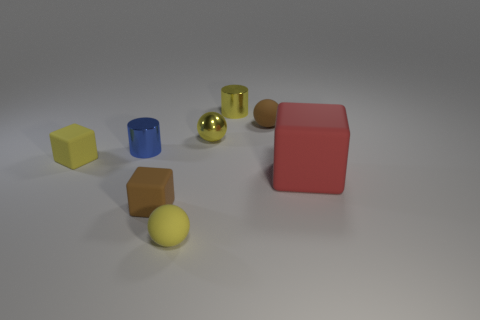There is a shiny object that is the same color as the small shiny sphere; what size is it?
Provide a succinct answer. Small. There is a small yellow shiny cylinder behind the big rubber thing; how many tiny brown things are to the left of it?
Provide a succinct answer. 1. What number of other things are made of the same material as the small brown sphere?
Ensure brevity in your answer.  4. Is the cube behind the big red block made of the same material as the small cylinder to the right of the yellow rubber sphere?
Offer a very short reply. No. Are there any other things that are the same shape as the big rubber object?
Offer a very short reply. Yes. Does the large cube have the same material as the cylinder that is to the right of the blue object?
Provide a short and direct response. No. What is the color of the tiny cylinder that is on the right side of the tiny shiny thing to the left of the tiny yellow sphere that is in front of the large matte thing?
Offer a very short reply. Yellow. What shape is the blue metallic thing that is the same size as the yellow cylinder?
Provide a succinct answer. Cylinder. Are there any other things that are the same size as the red matte thing?
Make the answer very short. No. Is the size of the yellow ball that is in front of the tiny blue cylinder the same as the matte block right of the brown cube?
Give a very brief answer. No. 